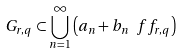Convert formula to latex. <formula><loc_0><loc_0><loc_500><loc_500>G _ { r , q } \subset \bigcup _ { n = 1 } ^ { \infty } \left ( a _ { n } + b _ { n } \ f f _ { r , q } \right )</formula> 